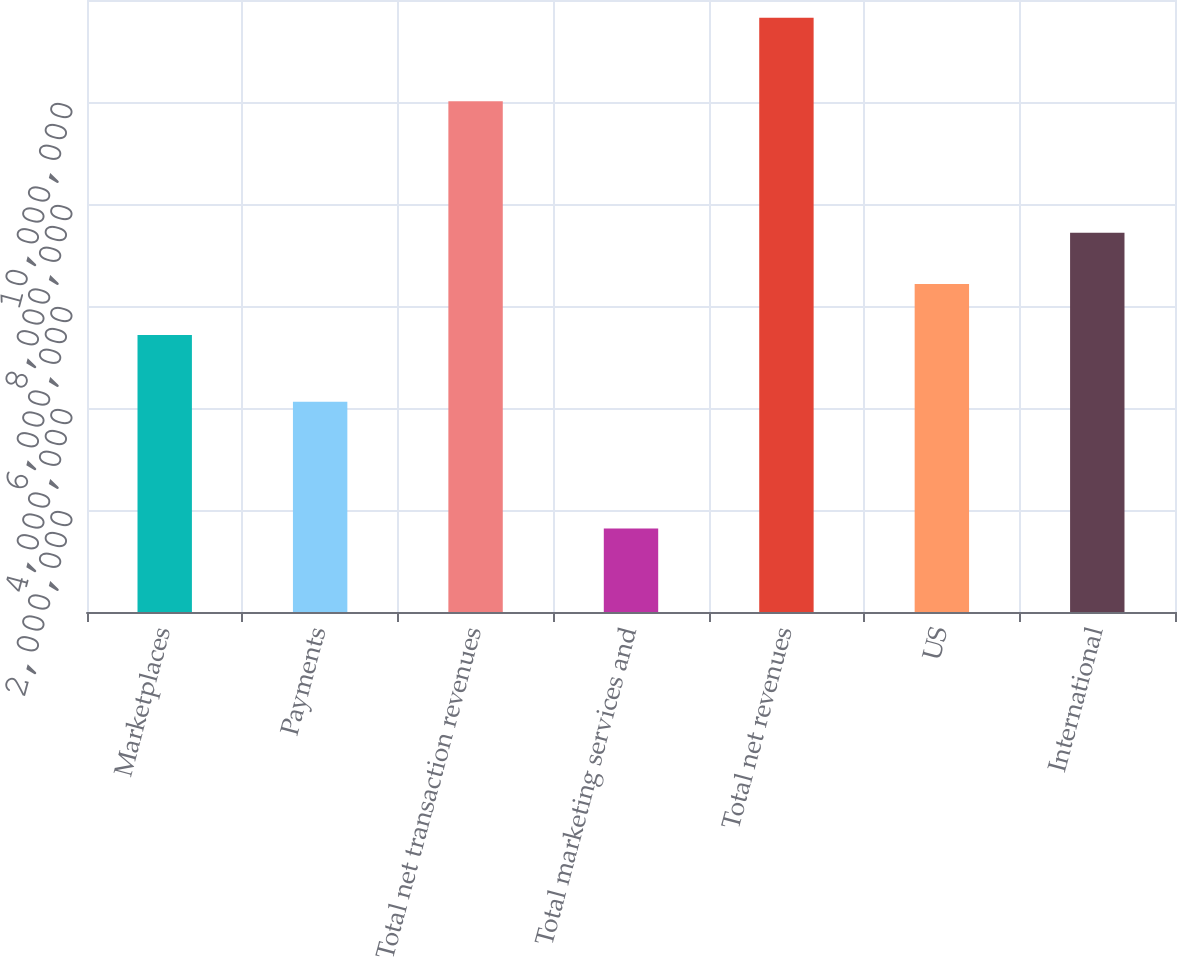<chart> <loc_0><loc_0><loc_500><loc_500><bar_chart><fcel>Marketplaces<fcel>Payments<fcel>Total net transaction revenues<fcel>Total marketing services and<fcel>Total net revenues<fcel>US<fcel>International<nl><fcel>5.43131e+06<fcel>4.1233e+06<fcel>1.00143e+07<fcel>1.63738e+06<fcel>1.16517e+07<fcel>6.43273e+06<fcel>7.43416e+06<nl></chart> 